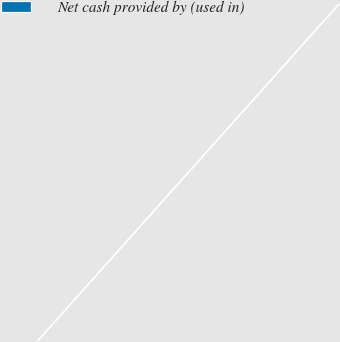<chart> <loc_0><loc_0><loc_500><loc_500><pie_chart><fcel>Net cash provided by (used in)<nl><fcel>100.0%<nl></chart> 